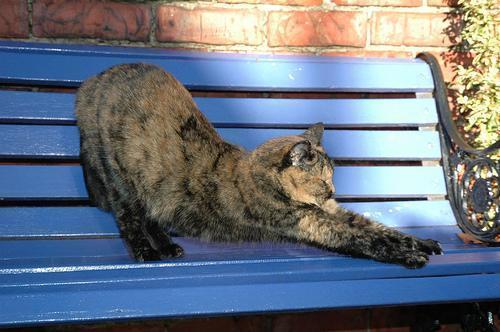How many cats?
Give a very brief answer. 1. How many legs?
Give a very brief answer. 4. How many people are on the bench?
Give a very brief answer. 0. How many cats are in the picture?
Give a very brief answer. 1. 